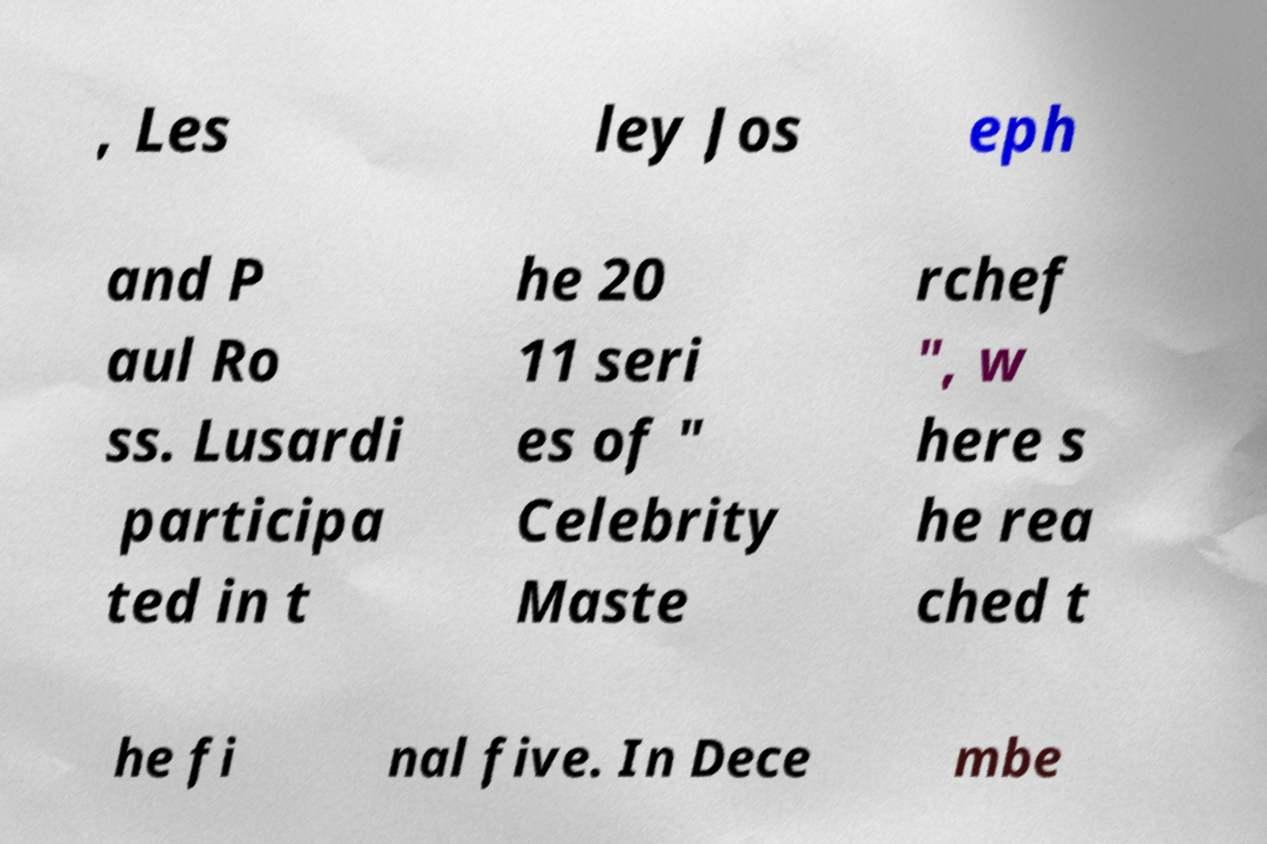For documentation purposes, I need the text within this image transcribed. Could you provide that? , Les ley Jos eph and P aul Ro ss. Lusardi participa ted in t he 20 11 seri es of " Celebrity Maste rchef ", w here s he rea ched t he fi nal five. In Dece mbe 